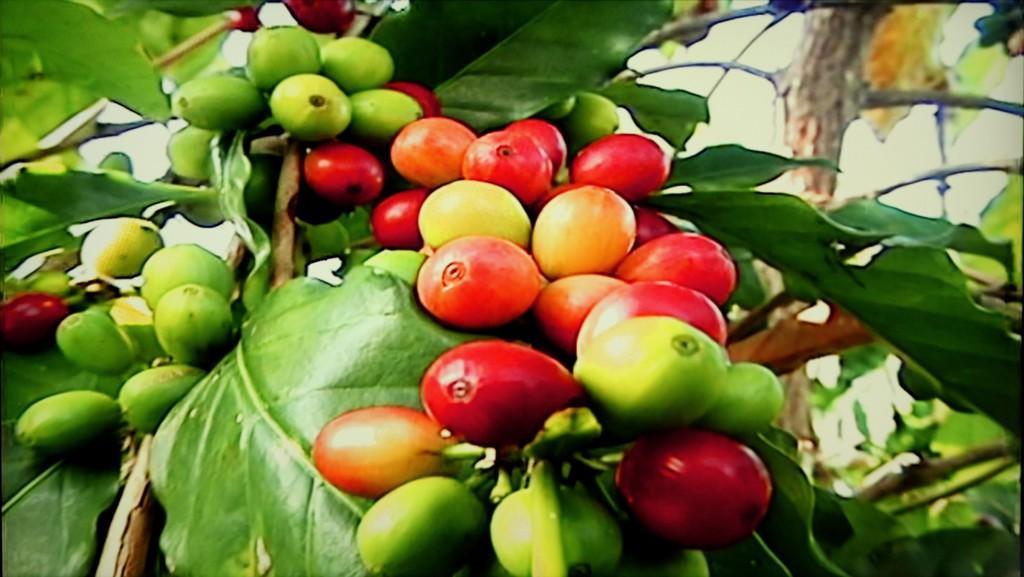Describe this image in one or two sentences. There are some ripen fruits and unripe fruits to the branch of the tree. 